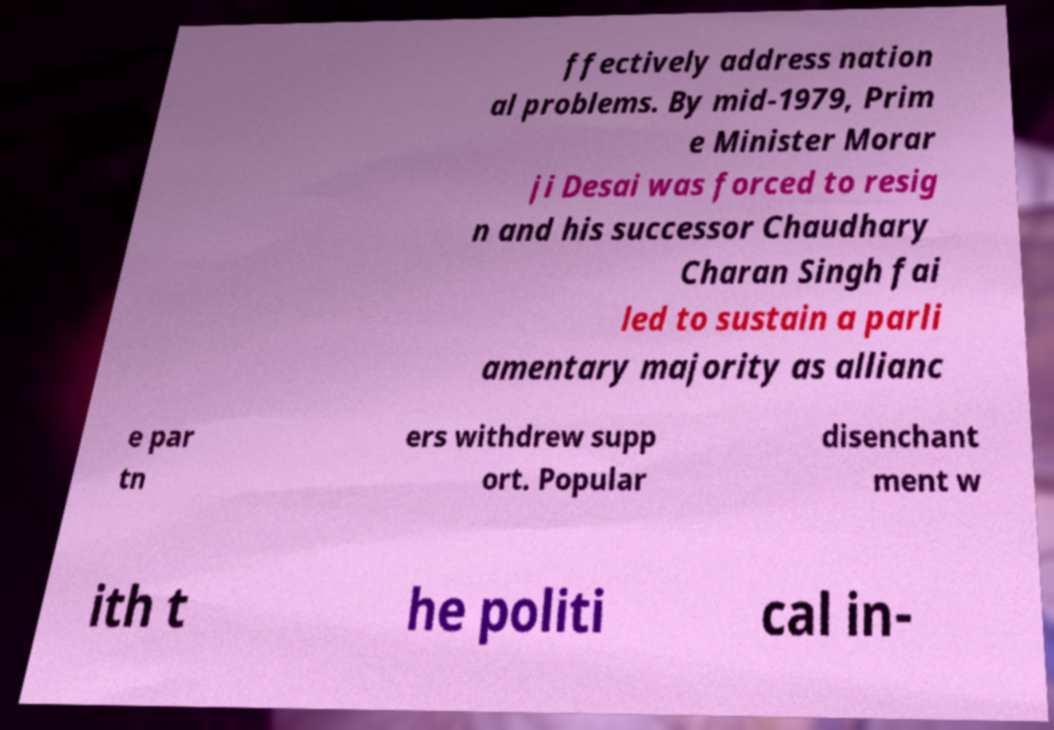For documentation purposes, I need the text within this image transcribed. Could you provide that? ffectively address nation al problems. By mid-1979, Prim e Minister Morar ji Desai was forced to resig n and his successor Chaudhary Charan Singh fai led to sustain a parli amentary majority as allianc e par tn ers withdrew supp ort. Popular disenchant ment w ith t he politi cal in- 